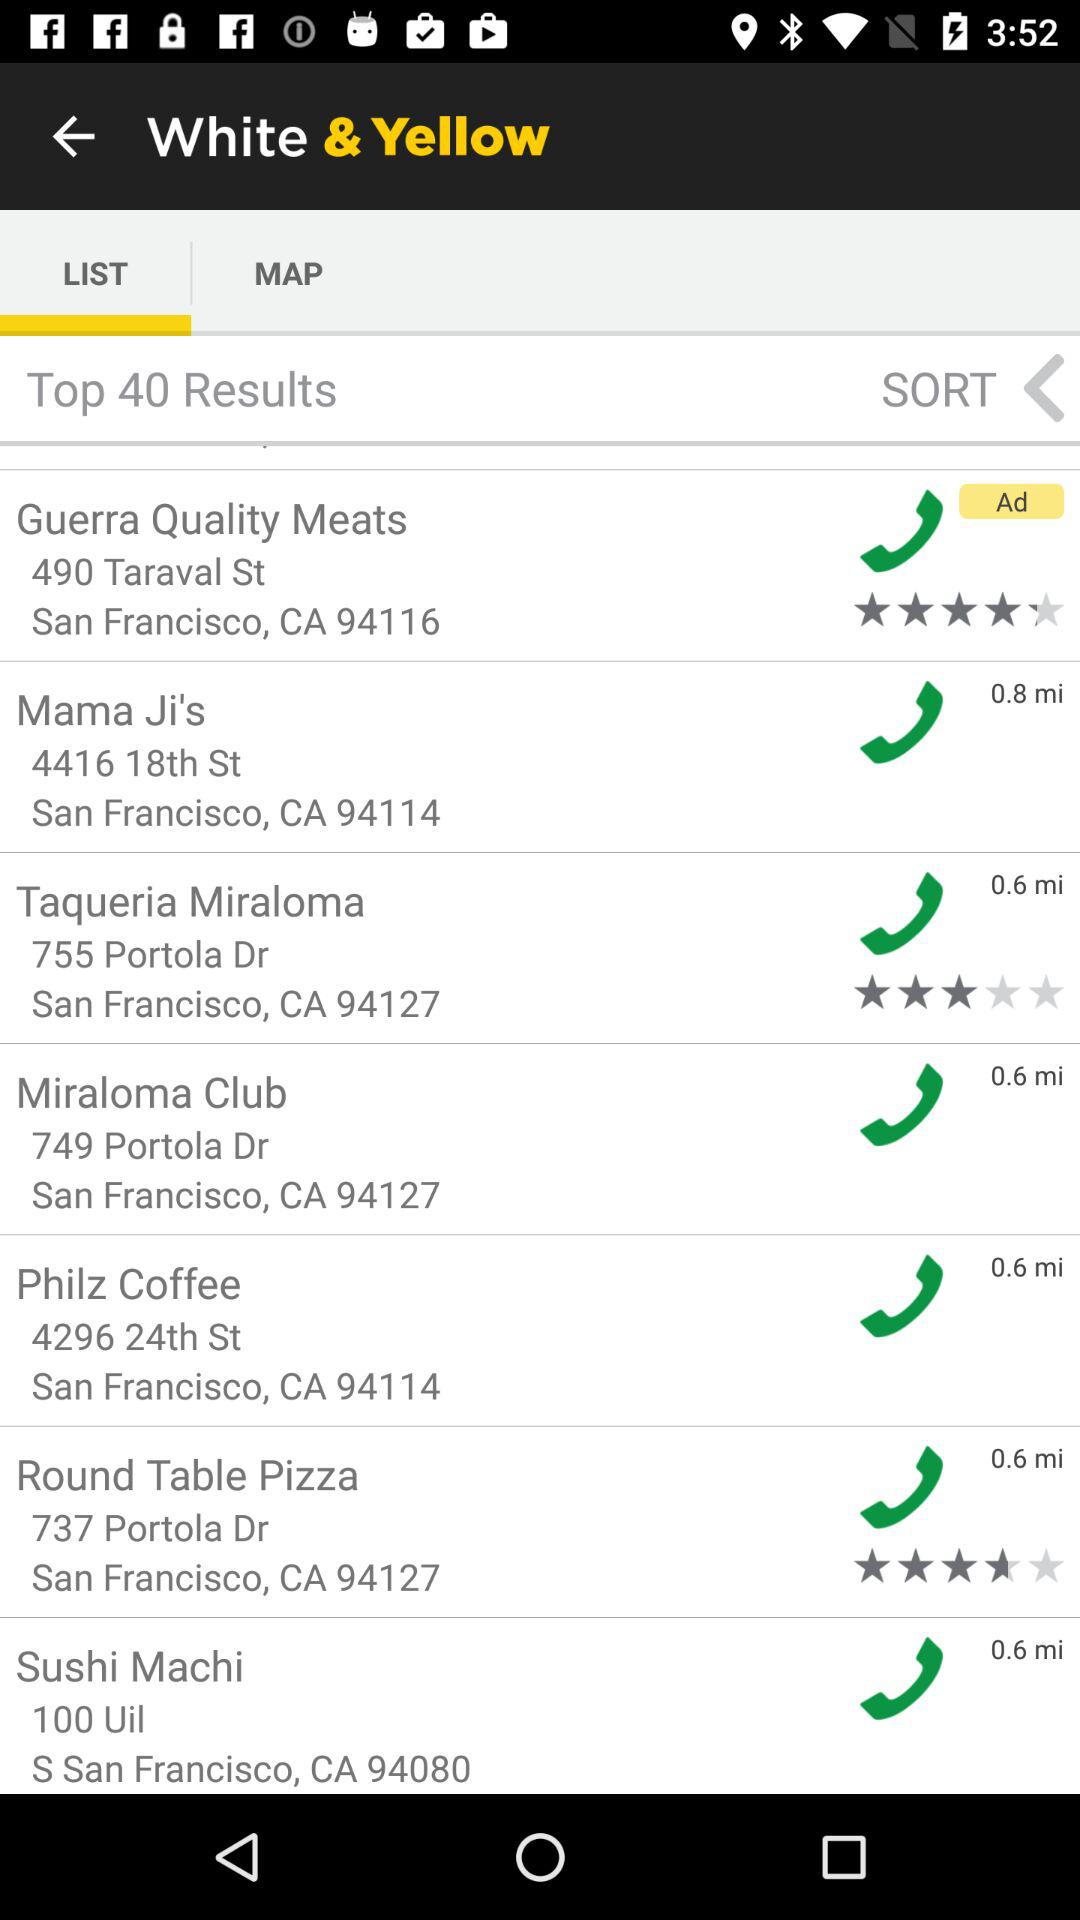How many top results in total are there? There are 40 top results in total. 